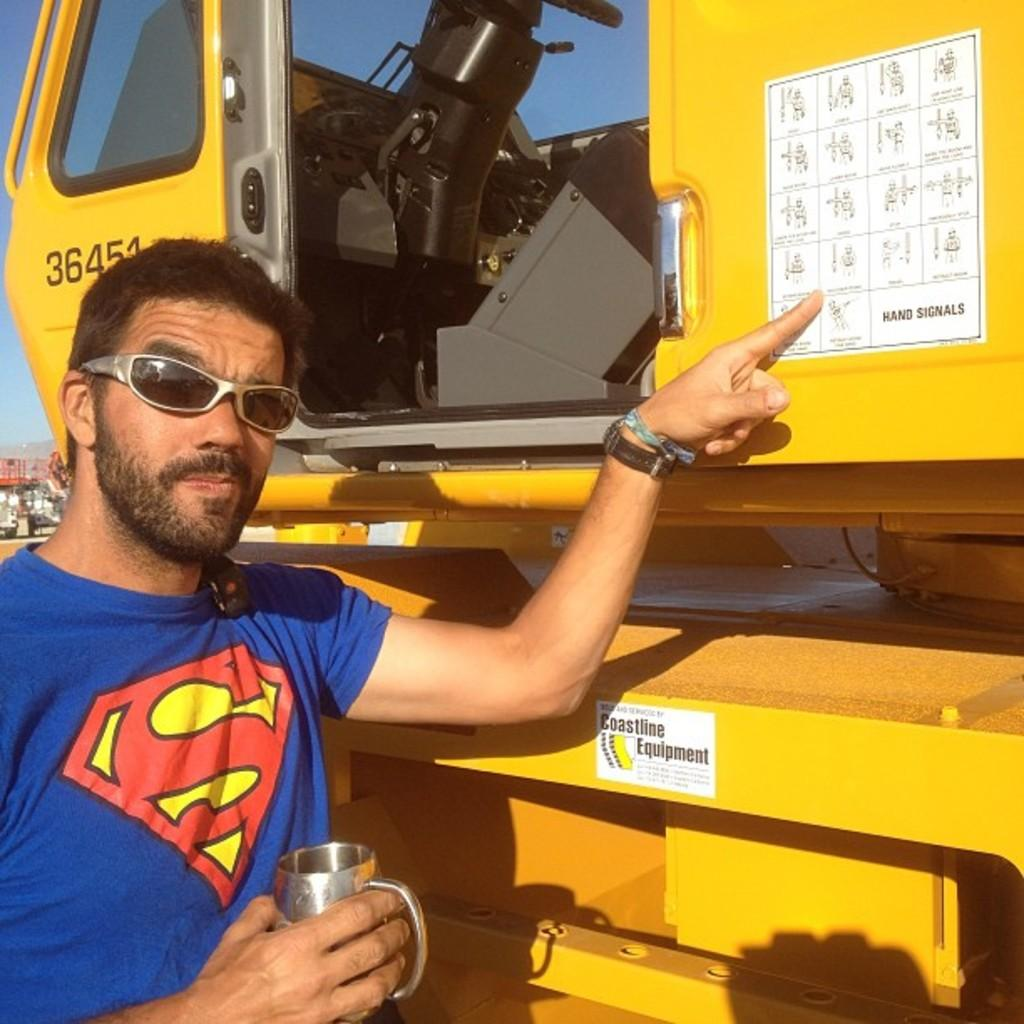What is the person in the image doing? The person is holding a cup in the image. What is the person wearing that is related to their activity? The person is wearing goggles. What else can be seen in the image besides the person? There is a vehicle in the image, and the sky is visible in the background. What is on the vehicle? There are posters on the vehicle. What type of lace can be seen on the person's shoes in the image? There is no mention of shoes or lace in the image; the person is wearing goggles. 